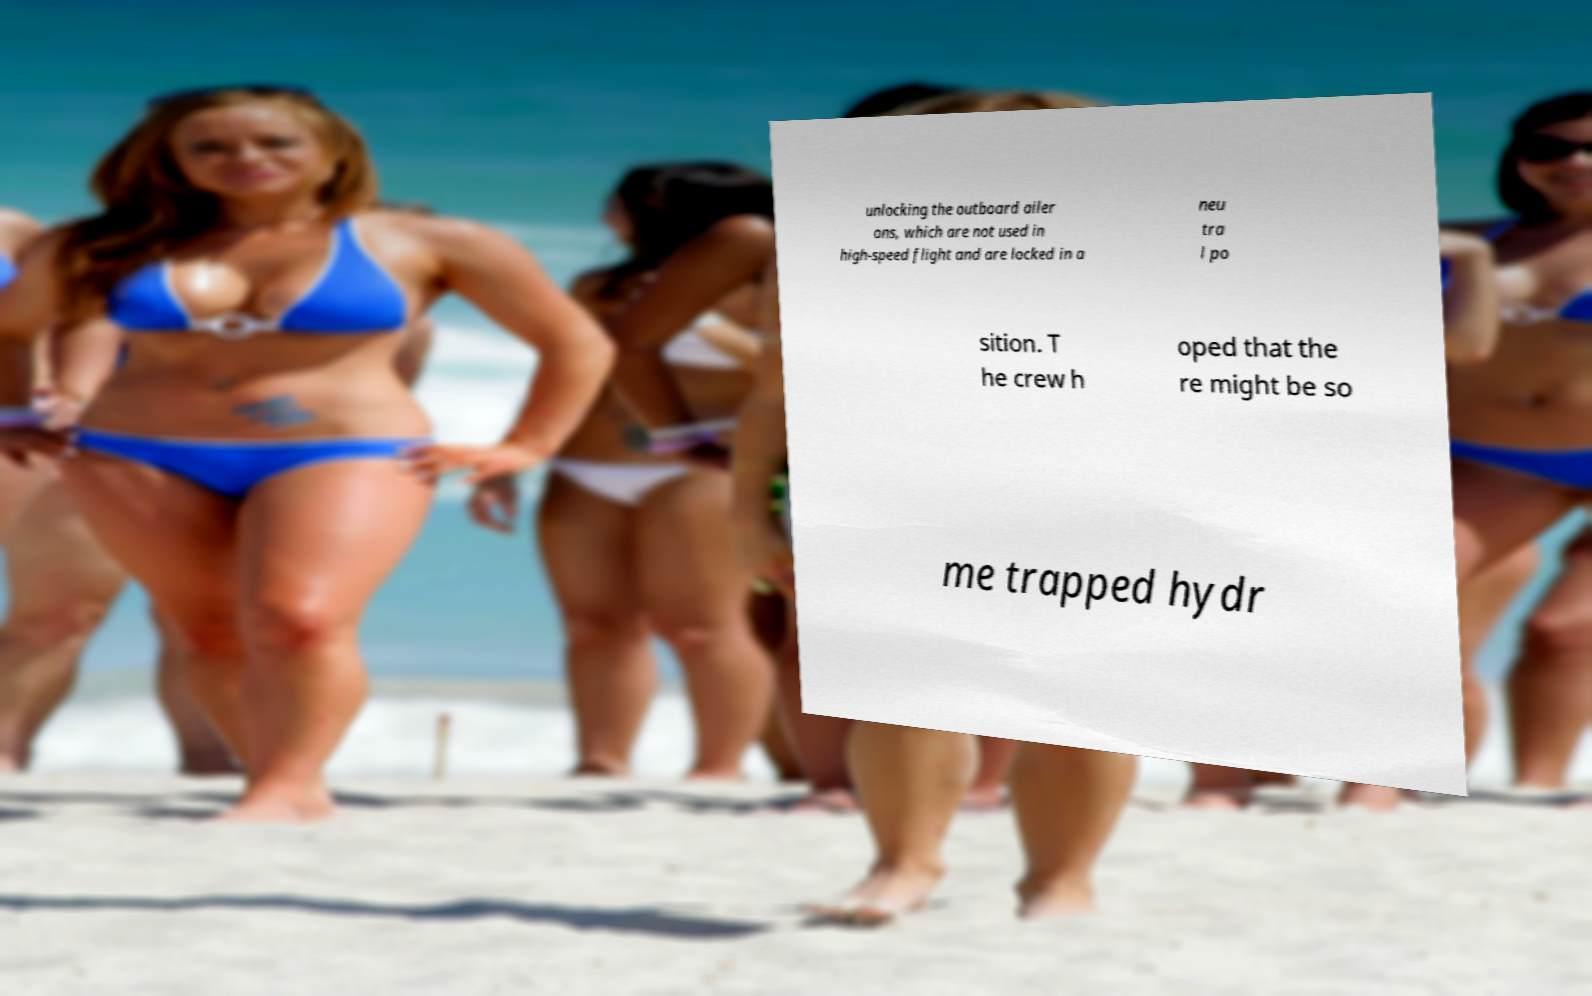Can you read and provide the text displayed in the image?This photo seems to have some interesting text. Can you extract and type it out for me? unlocking the outboard ailer ons, which are not used in high-speed flight and are locked in a neu tra l po sition. T he crew h oped that the re might be so me trapped hydr 